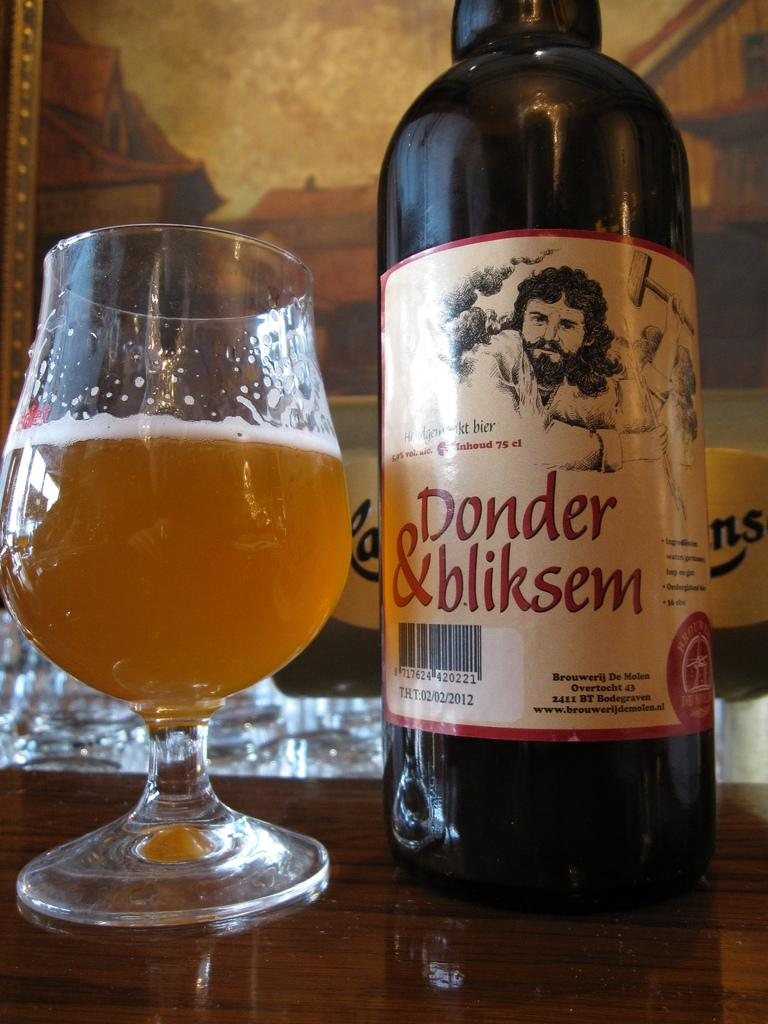<image>
Relay a brief, clear account of the picture shown. A bottle of Donder & bliksem with a glass next to it filled with beer. 